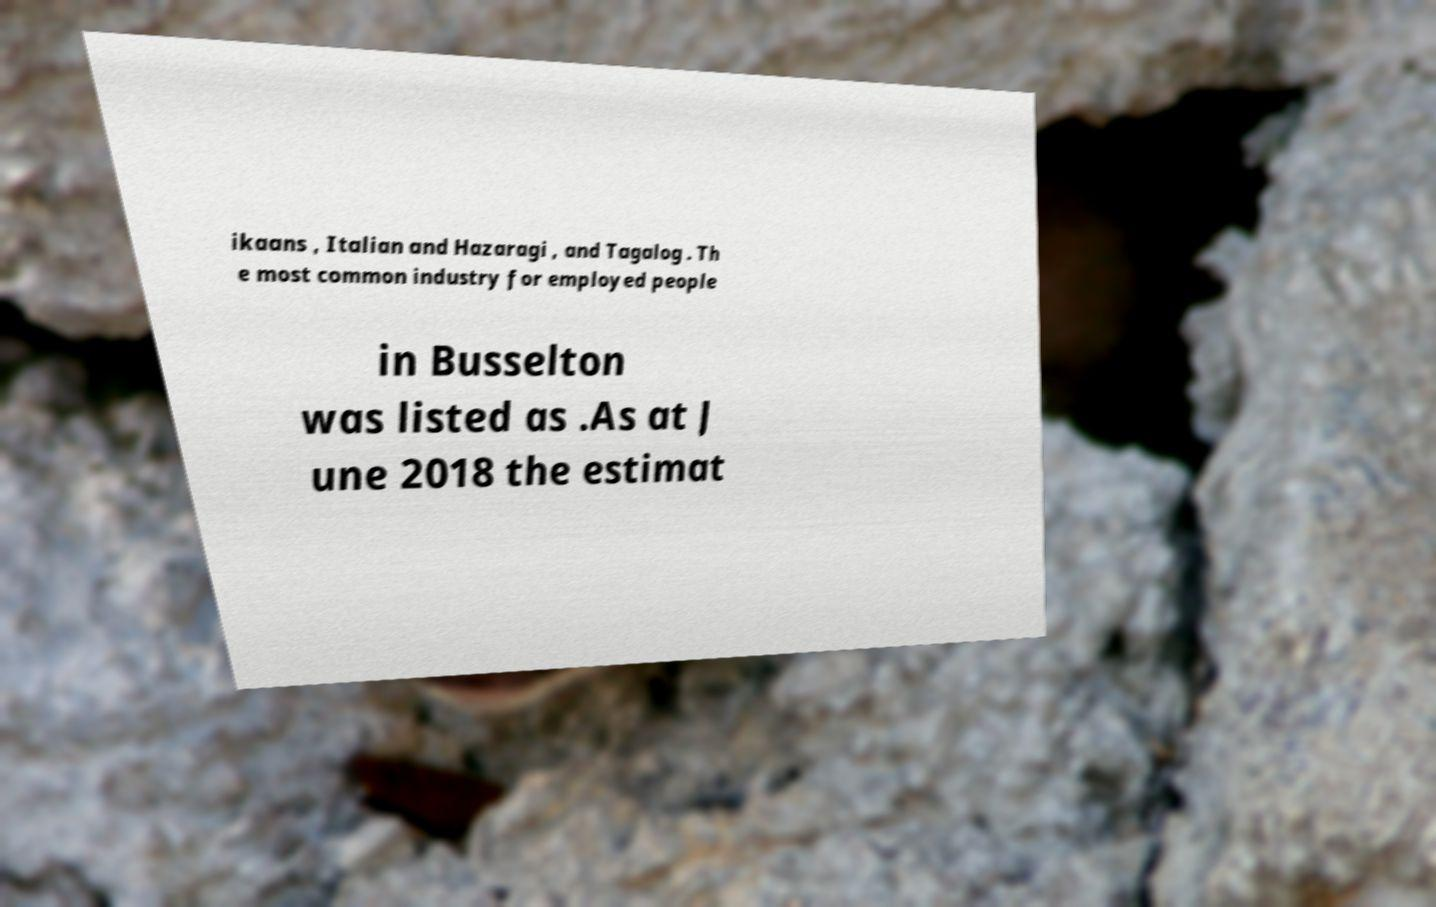What messages or text are displayed in this image? I need them in a readable, typed format. ikaans , Italian and Hazaragi , and Tagalog . Th e most common industry for employed people in Busselton was listed as .As at J une 2018 the estimat 